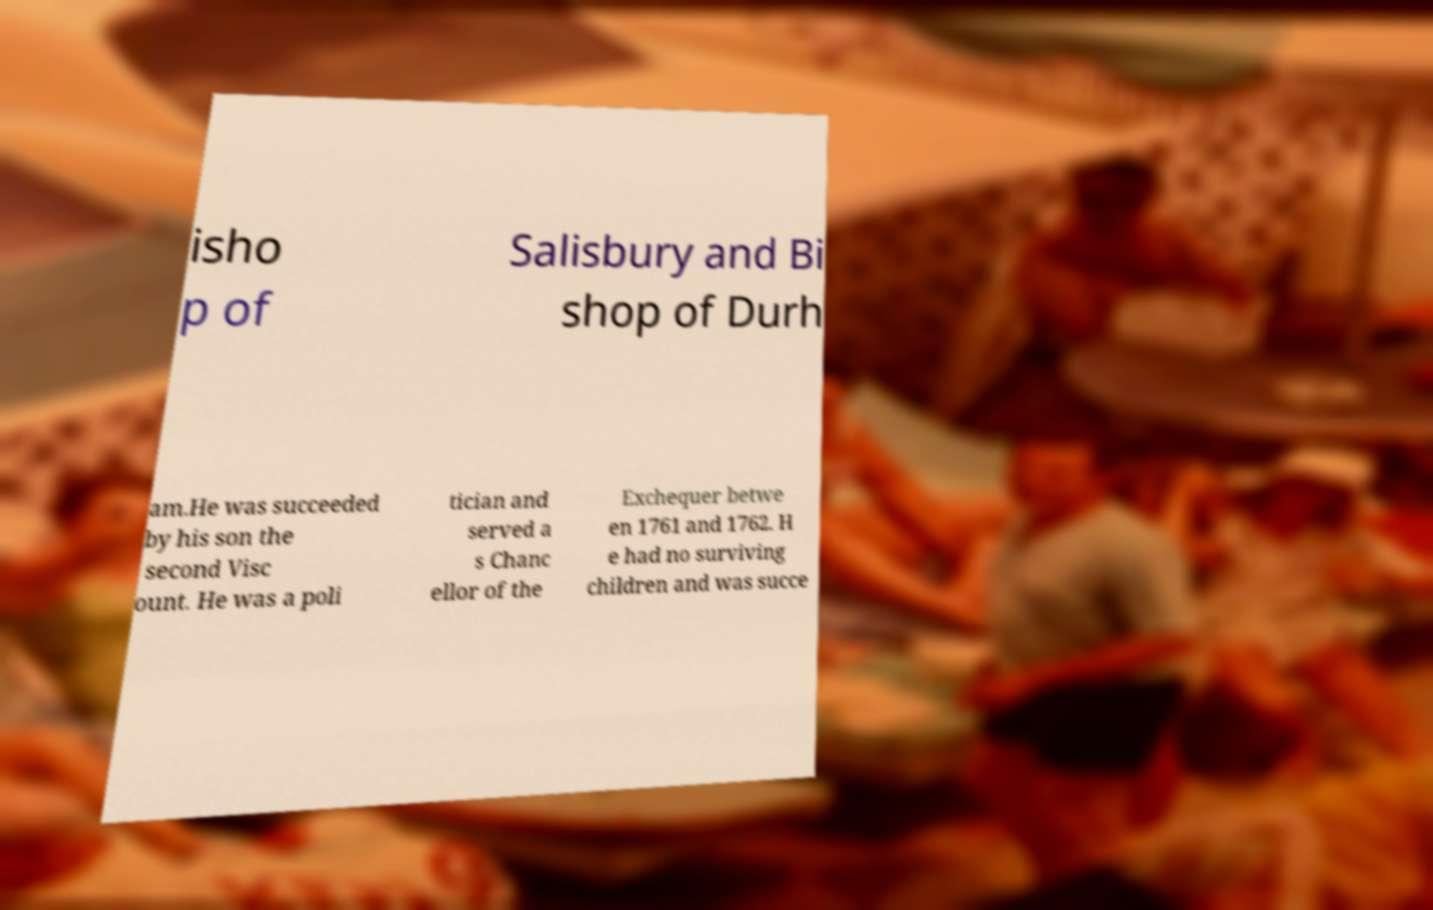There's text embedded in this image that I need extracted. Can you transcribe it verbatim? isho p of Salisbury and Bi shop of Durh am.He was succeeded by his son the second Visc ount. He was a poli tician and served a s Chanc ellor of the Exchequer betwe en 1761 and 1762. H e had no surviving children and was succe 